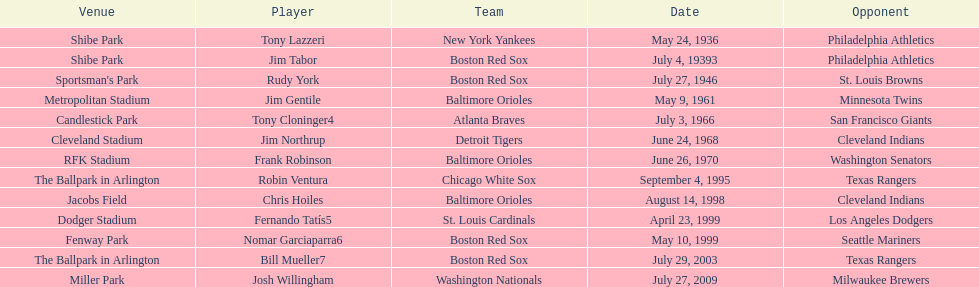Who is the first major league hitter to hit two grand slams in one game? Tony Lazzeri. Write the full table. {'header': ['Venue', 'Player', 'Team', 'Date', 'Opponent'], 'rows': [['Shibe Park', 'Tony Lazzeri', 'New York Yankees', 'May 24, 1936', 'Philadelphia Athletics'], ['Shibe Park', 'Jim Tabor', 'Boston Red Sox', 'July 4, 19393', 'Philadelphia Athletics'], ["Sportsman's Park", 'Rudy York', 'Boston Red Sox', 'July 27, 1946', 'St. Louis Browns'], ['Metropolitan Stadium', 'Jim Gentile', 'Baltimore Orioles', 'May 9, 1961', 'Minnesota Twins'], ['Candlestick Park', 'Tony Cloninger4', 'Atlanta Braves', 'July 3, 1966', 'San Francisco Giants'], ['Cleveland Stadium', 'Jim Northrup', 'Detroit Tigers', 'June 24, 1968', 'Cleveland Indians'], ['RFK Stadium', 'Frank Robinson', 'Baltimore Orioles', 'June 26, 1970', 'Washington Senators'], ['The Ballpark in Arlington', 'Robin Ventura', 'Chicago White Sox', 'September 4, 1995', 'Texas Rangers'], ['Jacobs Field', 'Chris Hoiles', 'Baltimore Orioles', 'August 14, 1998', 'Cleveland Indians'], ['Dodger Stadium', 'Fernando Tatís5', 'St. Louis Cardinals', 'April 23, 1999', 'Los Angeles Dodgers'], ['Fenway Park', 'Nomar Garciaparra6', 'Boston Red Sox', 'May 10, 1999', 'Seattle Mariners'], ['The Ballpark in Arlington', 'Bill Mueller7', 'Boston Red Sox', 'July 29, 2003', 'Texas Rangers'], ['Miller Park', 'Josh Willingham', 'Washington Nationals', 'July 27, 2009', 'Milwaukee Brewers']]} 